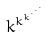<formula> <loc_0><loc_0><loc_500><loc_500>k ^ { k ^ { k ^ { \cdot ^ { \cdot ^ { \cdot } } } } }</formula> 